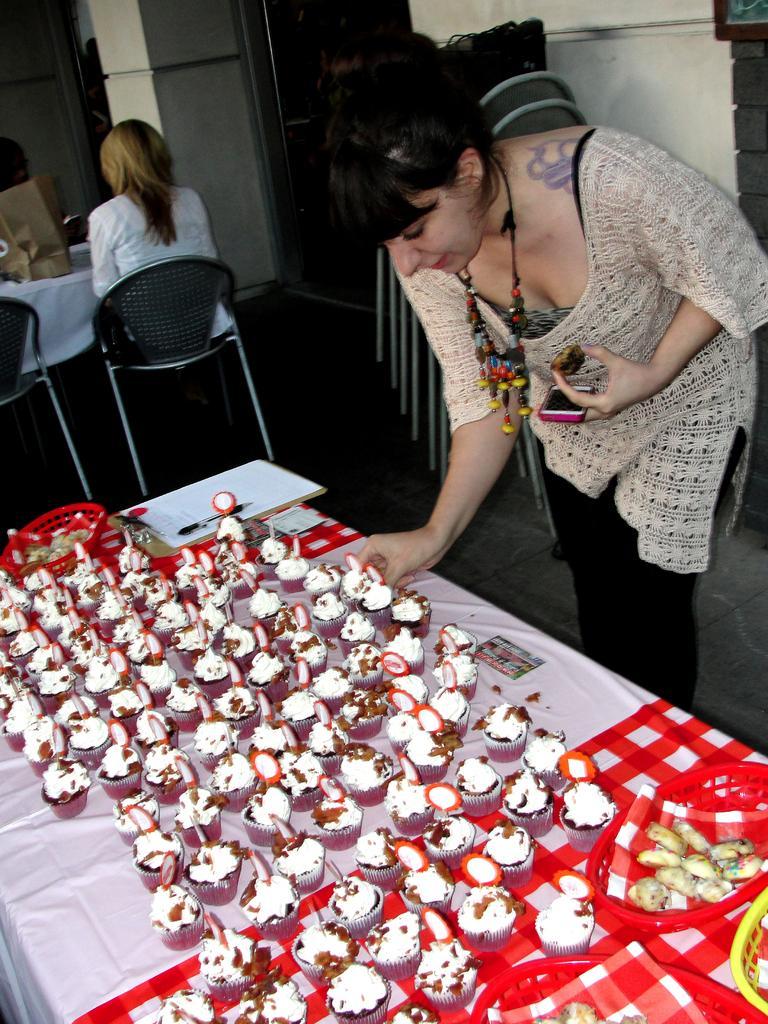In one or two sentences, can you explain what this image depicts? In the image we can see there is a woman who is standing and on the table there are lot of cup cakes and at the back the woman is sitting on chair. 